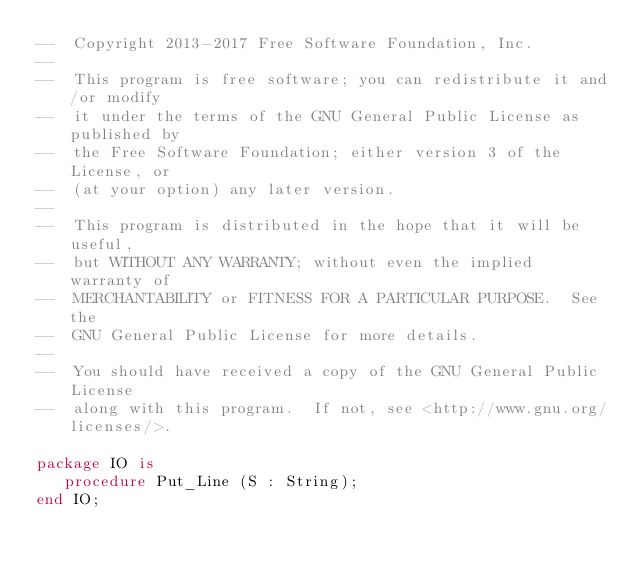<code> <loc_0><loc_0><loc_500><loc_500><_Ada_>--  Copyright 2013-2017 Free Software Foundation, Inc.
--
--  This program is free software; you can redistribute it and/or modify
--  it under the terms of the GNU General Public License as published by
--  the Free Software Foundation; either version 3 of the License, or
--  (at your option) any later version.
--
--  This program is distributed in the hope that it will be useful,
--  but WITHOUT ANY WARRANTY; without even the implied warranty of
--  MERCHANTABILITY or FITNESS FOR A PARTICULAR PURPOSE.  See the
--  GNU General Public License for more details.
--
--  You should have received a copy of the GNU General Public License
--  along with this program.  If not, see <http://www.gnu.org/licenses/>.

package IO is
   procedure Put_Line (S : String);
end IO;
</code> 